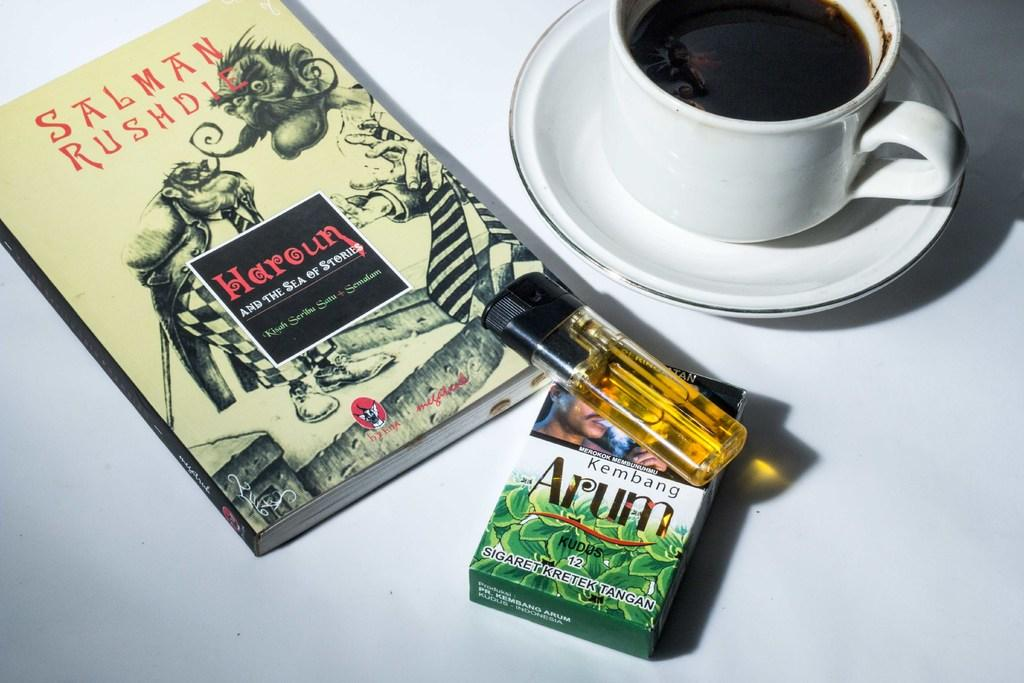<image>
Present a compact description of the photo's key features. A book, by Salman Rushdie, is next to a cup of coffee and a pack of cigarettes. 